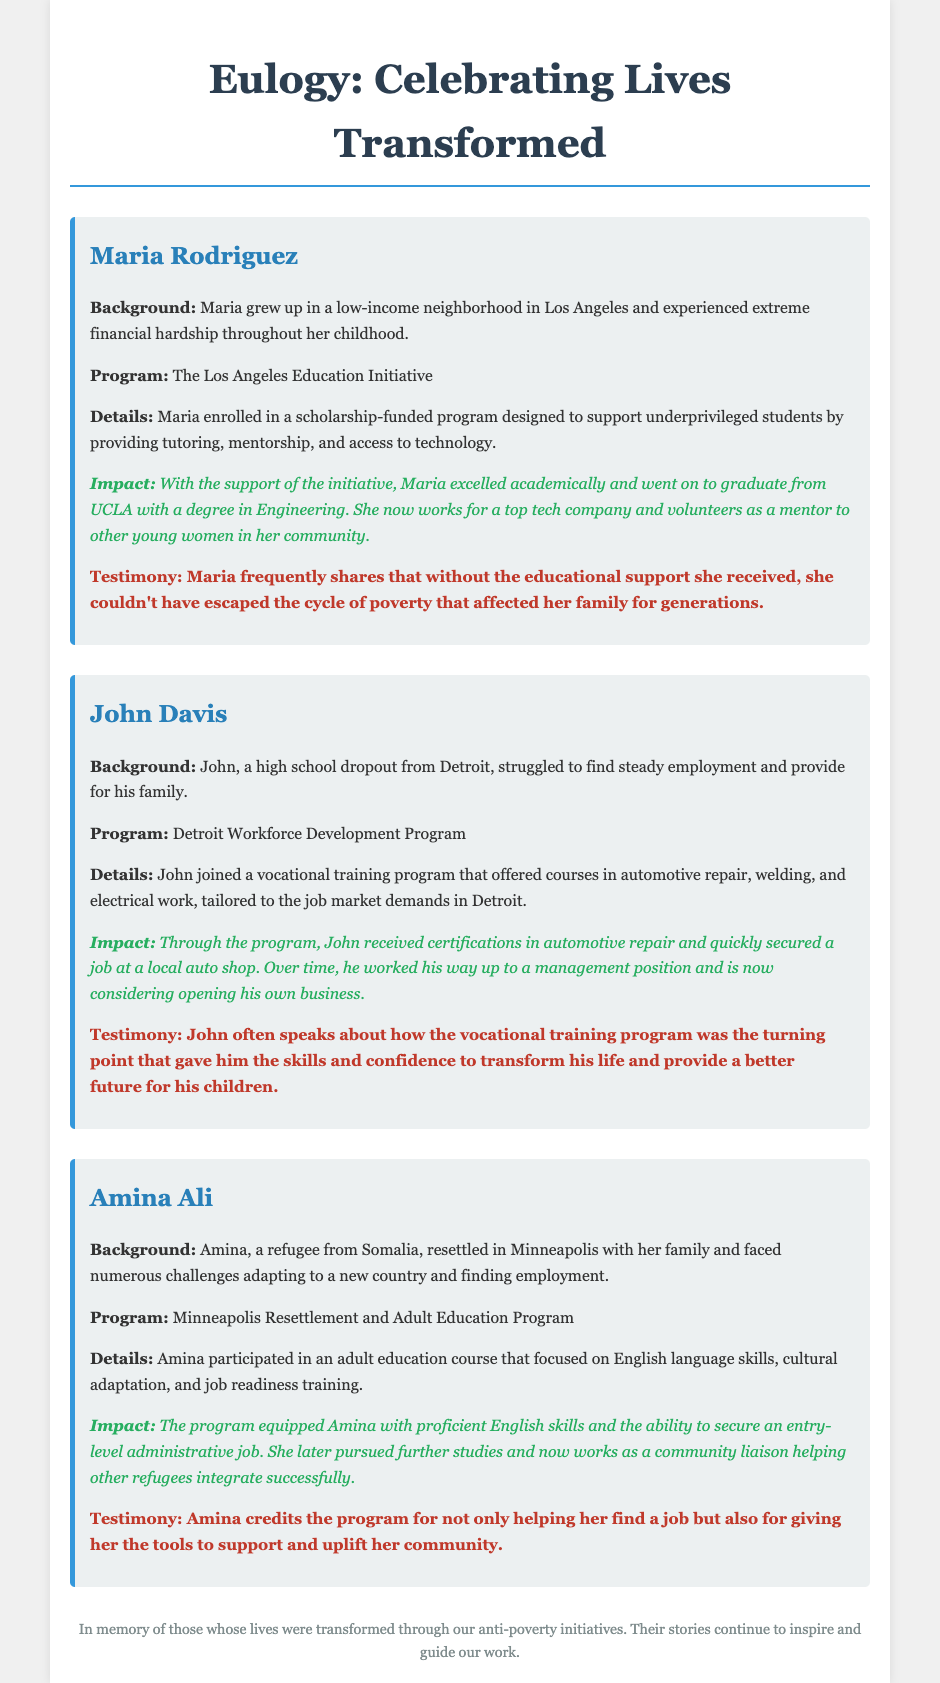What is the name of the initiative that Maria Rodriguez benefited from? The document states that Maria enrolled in the Los Angeles Education Initiative program.
Answer: Los Angeles Education Initiative What type of program did John Davis participate in? John joined a vocational training program, specifically for automotive repair, welding, and electrical work.
Answer: Vocational training program What degree did Maria earn? The document mentions that Maria graduated from UCLA with a degree in Engineering.
Answer: Engineering How did Amina Ali improve her English skills? Amina participated in an adult education course focused on English language skills.
Answer: Adult education course What job does Amina currently hold? Amina now works as a community liaison helping other refugees integrate successfully.
Answer: Community liaison What was John Davis's previous educational status? John was a high school dropout before joining the vocational training program.
Answer: High school dropout What city did Amina Ali resettle in? Amina resettled in Minneapolis with her family.
Answer: Minneapolis What role does Maria Rodriguez take in her community now? Maria volunteers as a mentor to other young women in her community.
Answer: Mentor 